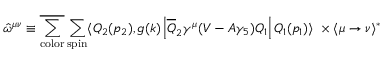<formula> <loc_0><loc_0><loc_500><loc_500>{ \hat { \omega } } ^ { \mu \nu } \equiv \overline { { { \sum _ { c o l o r } } } } \sum _ { s p i n } \langle Q _ { 2 } ( p _ { 2 } ) , g ( k ) \left | { \overline { Q } } _ { 2 } \gamma ^ { \mu } ( V - A \gamma _ { 5 } ) Q _ { 1 } \right | Q _ { 1 } ( p _ { 1 } ) \rangle \ \times \langle \mu \rightarrow \nu \rangle ^ { \ast }</formula> 